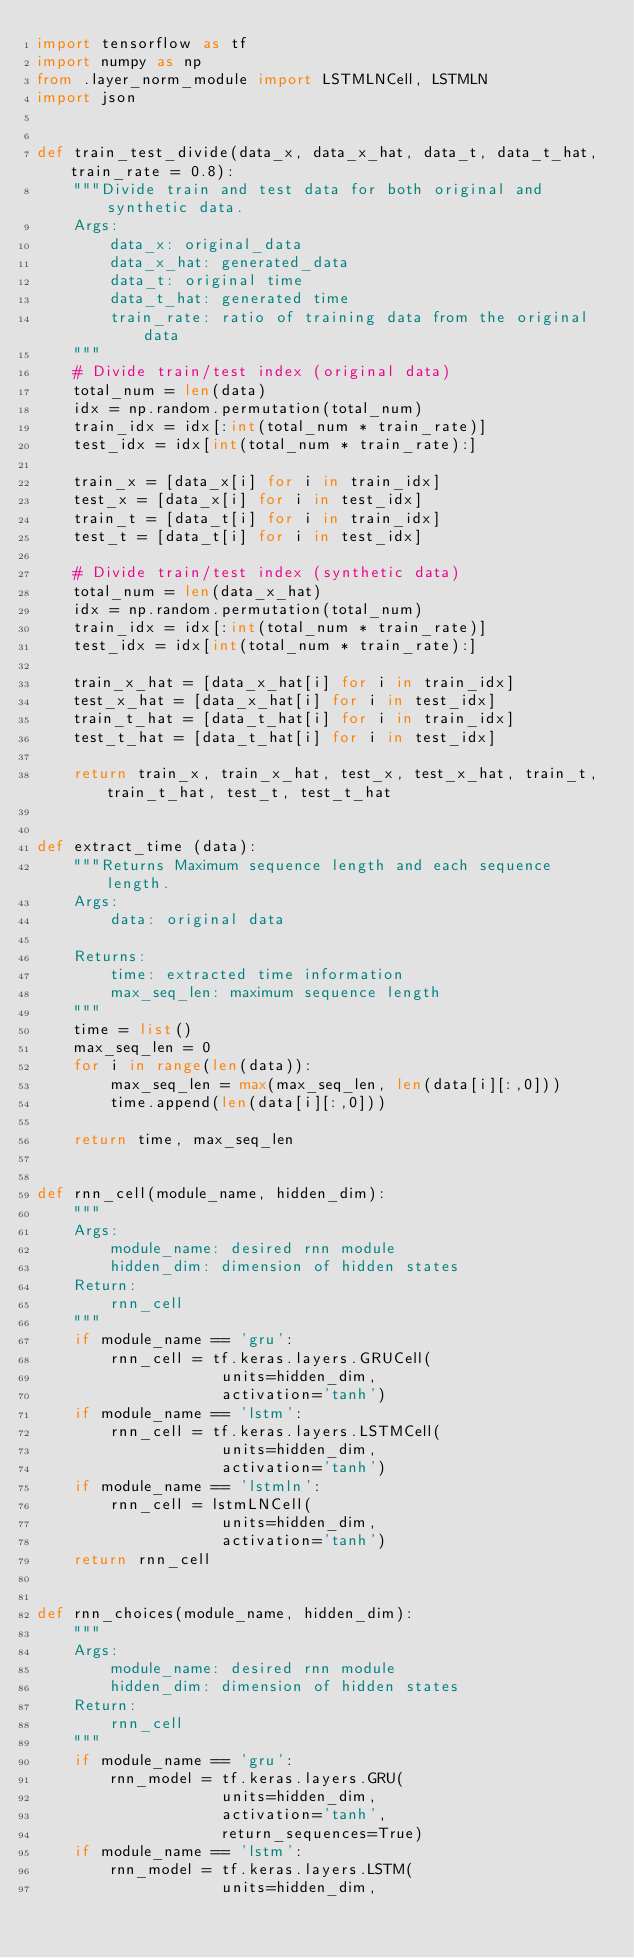Convert code to text. <code><loc_0><loc_0><loc_500><loc_500><_Python_>import tensorflow as tf
import numpy as np
from .layer_norm_module import LSTMLNCell, LSTMLN
import json


def train_test_divide(data_x, data_x_hat, data_t, data_t_hat, train_rate = 0.8):
    """Divide train and test data for both original and synthetic data.
    Args:
        data_x: original_data
        data_x_hat: generated_data
        data_t: original time
        data_t_hat: generated time
        train_rate: ratio of training data from the original data
    """
    # Divide train/test index (original data)
    total_num = len(data)
    idx = np.random.permutation(total_num)
    train_idx = idx[:int(total_num * train_rate)]
    test_idx = idx[int(total_num * train_rate):]

    train_x = [data_x[i] for i in train_idx]
    test_x = [data_x[i] for i in test_idx]
    train_t = [data_t[i] for i in train_idx]
    test_t = [data_t[i] for i in test_idx]

    # Divide train/test index (synthetic data)
    total_num = len(data_x_hat)
    idx = np.random.permutation(total_num)
    train_idx = idx[:int(total_num * train_rate)]
    test_idx = idx[int(total_num * train_rate):]
  
    train_x_hat = [data_x_hat[i] for i in train_idx]
    test_x_hat = [data_x_hat[i] for i in test_idx]
    train_t_hat = [data_t_hat[i] for i in train_idx]
    test_t_hat = [data_t_hat[i] for i in test_idx]

    return train_x, train_x_hat, test_x, test_x_hat, train_t, train_t_hat, test_t, test_t_hat


def extract_time (data):
    """Returns Maximum sequence length and each sequence length.
    Args:
        data: original data
    
    Returns:
        time: extracted time information
        max_seq_len: maximum sequence length
    """
    time = list()
    max_seq_len = 0
    for i in range(len(data)):
        max_seq_len = max(max_seq_len, len(data[i][:,0]))
        time.append(len(data[i][:,0]))
    
    return time, max_seq_len


def rnn_cell(module_name, hidden_dim):
    """
    Args:
        module_name: desired rnn module
        hidden_dim: dimension of hidden states
    Return:
        rnn_cell
    """
    if module_name == 'gru':
        rnn_cell = tf.keras.layers.GRUCell(
                    units=hidden_dim,
                    activation='tanh')
    if module_name == 'lstm':
        rnn_cell = tf.keras.layers.LSTMCell(
                    units=hidden_dim,
                    activation='tanh')
    if module_name == 'lstmln':
        rnn_cell = lstmLNCell(
                    units=hidden_dim,
                    activation='tanh')
    return rnn_cell


def rnn_choices(module_name, hidden_dim):
    """
    Args:
        module_name: desired rnn module
        hidden_dim: dimension of hidden states
    Return:
        rnn_cell
    """
    if module_name == 'gru':
        rnn_model = tf.keras.layers.GRU(
                    units=hidden_dim,
                    activation='tanh',
                    return_sequences=True)
    if module_name == 'lstm':
        rnn_model = tf.keras.layers.LSTM(
                    units=hidden_dim,</code> 